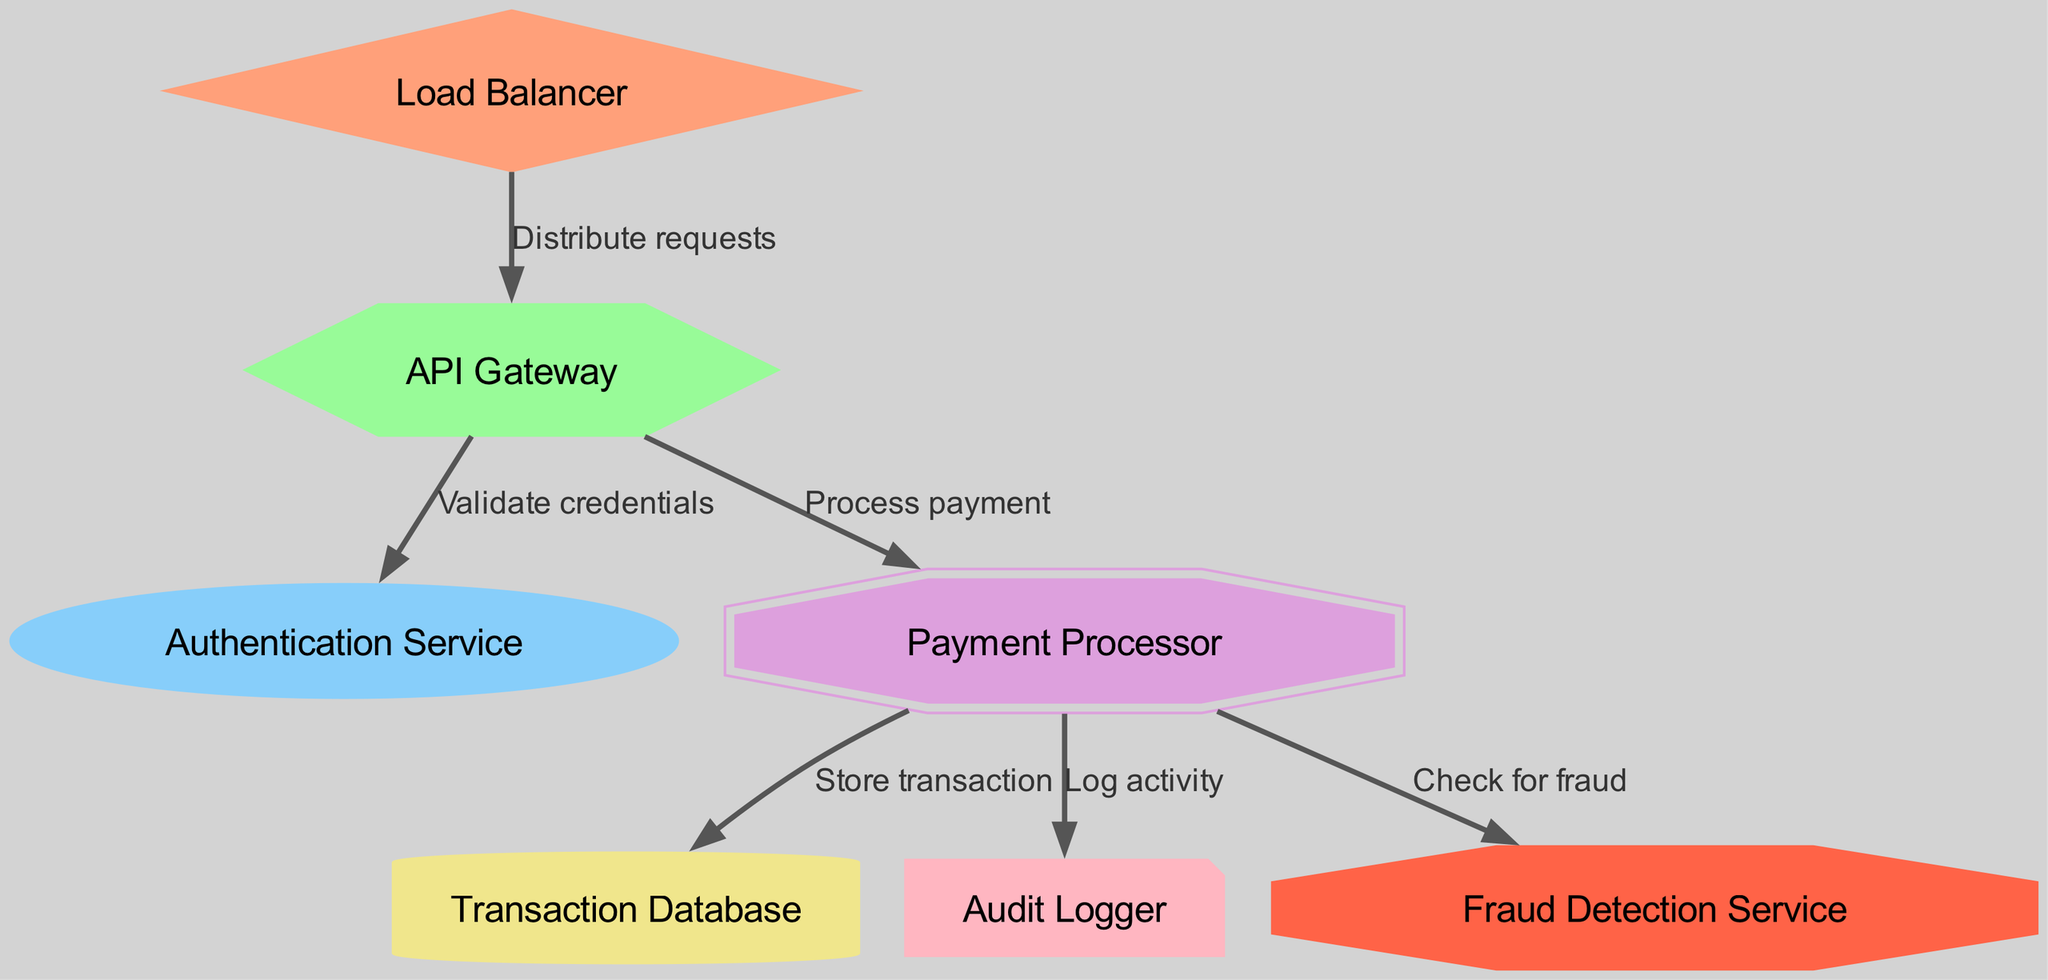What is the total number of nodes in the diagram? The diagram lists nodes such as the API Gateway, Authentication Service, Payment Processor, Transaction Database, Audit Logger, Fraud Detection Service, and Load Balancer. Counting these, there are seven nodes in total.
Answer: Seven What shape represents the Load Balancer in the diagram? The Load Balancer node is illustrated as a diamond shape according to the custom styles applied in the diagram.
Answer: Diamond Which service validates credentials in the workflow? The API Gateway connects to the Authentication Service specifically for the purpose of validating credentials as shown by the edge label.
Answer: Authentication Service How many edges connect the Payment Processor to other nodes? The Payment Processor has three outgoing edges connecting it to the Transaction Database, Audit Logger, and Fraud Detection Service, which can be verified by counting the outgoing connections from this node.
Answer: Three Which component is responsible for auditing activities within the system? The edge from the Payment Processor to the Audit Logger indicates that the Audit Logger service is responsible for logging activities, which is specifically labeled in the diagram.
Answer: Audit Logger What is the function of the Fraud Detection Service in the architecture? The Payment Processor checks for fraud by connecting to the Fraud Detection Service as indicated by the edge label describing this relationship, which suggests its role within the payment processing system.
Answer: Check for fraud Where does the Load Balancer distribute requests? The diagram shows the Load Balancer directing requests to the API Gateway, which is represented by the edge label for that connection, indicating its role in managing incoming traffic.
Answer: API Gateway Which component is visually represented as a hexagon? The API Gateway node is depicted in a hexagon shape in the diagram, as specified in the custom styles for that node.
Answer: API Gateway 